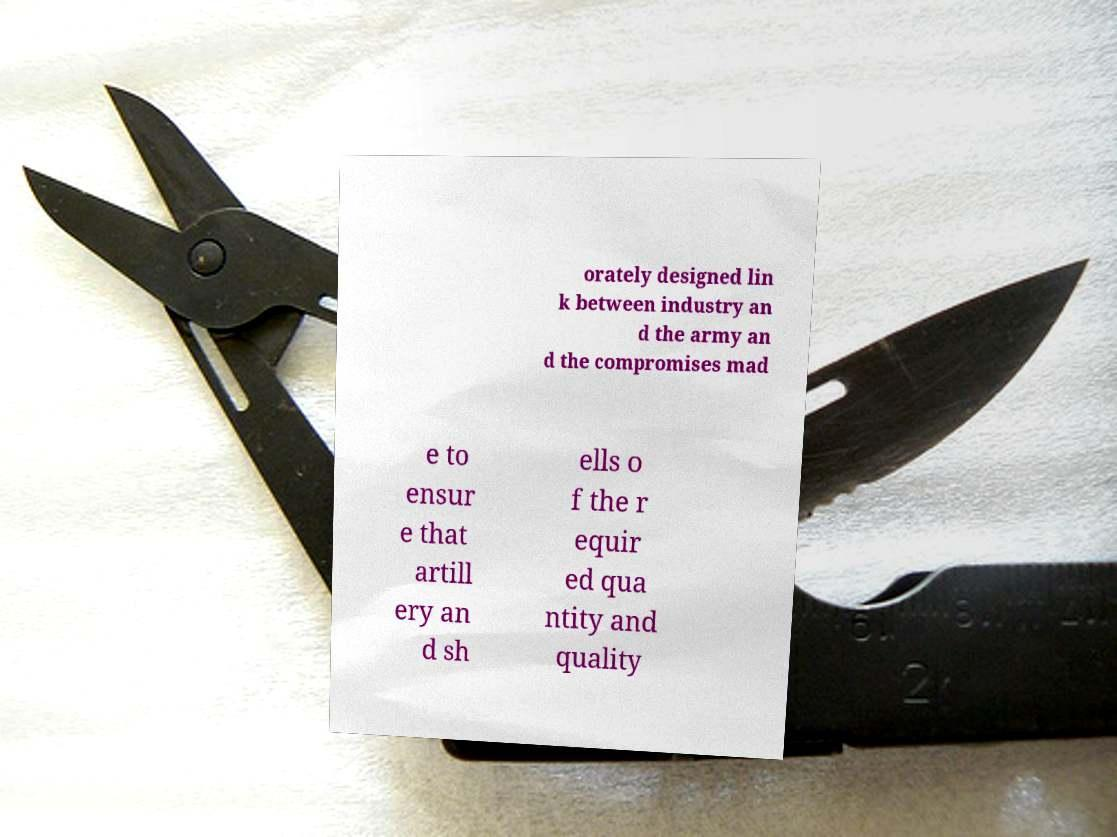There's text embedded in this image that I need extracted. Can you transcribe it verbatim? orately designed lin k between industry an d the army an d the compromises mad e to ensur e that artill ery an d sh ells o f the r equir ed qua ntity and quality 